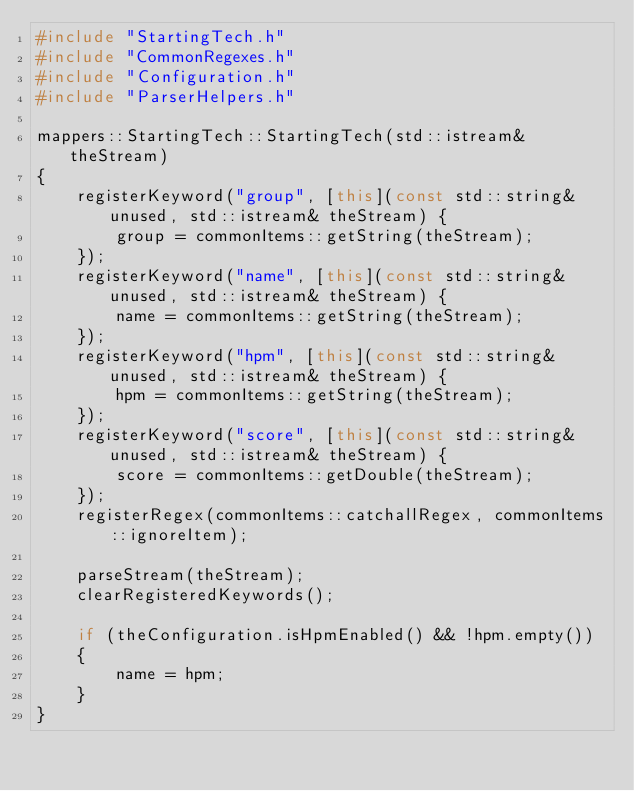<code> <loc_0><loc_0><loc_500><loc_500><_C++_>#include "StartingTech.h"
#include "CommonRegexes.h"
#include "Configuration.h"
#include "ParserHelpers.h"

mappers::StartingTech::StartingTech(std::istream& theStream)
{
	registerKeyword("group", [this](const std::string& unused, std::istream& theStream) {
		group = commonItems::getString(theStream);
	});
	registerKeyword("name", [this](const std::string& unused, std::istream& theStream) {
		name = commonItems::getString(theStream);
	});
	registerKeyword("hpm", [this](const std::string& unused, std::istream& theStream) {
		hpm = commonItems::getString(theStream);
	});
	registerKeyword("score", [this](const std::string& unused, std::istream& theStream) {
		score = commonItems::getDouble(theStream);
	});
	registerRegex(commonItems::catchallRegex, commonItems::ignoreItem);

	parseStream(theStream);
	clearRegisteredKeywords();

	if (theConfiguration.isHpmEnabled() && !hpm.empty())
	{
		name = hpm;
	}
}</code> 